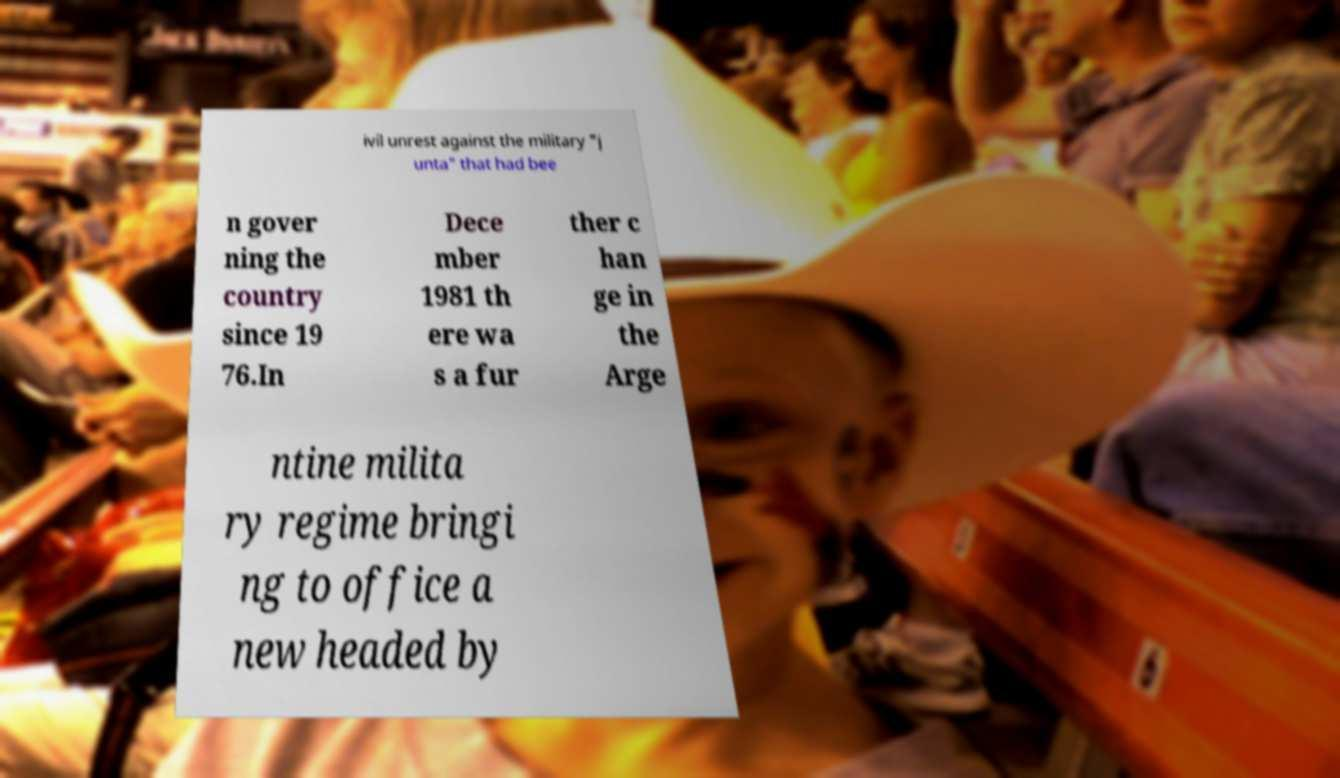Can you accurately transcribe the text from the provided image for me? ivil unrest against the military "j unta" that had bee n gover ning the country since 19 76.In Dece mber 1981 th ere wa s a fur ther c han ge in the Arge ntine milita ry regime bringi ng to office a new headed by 